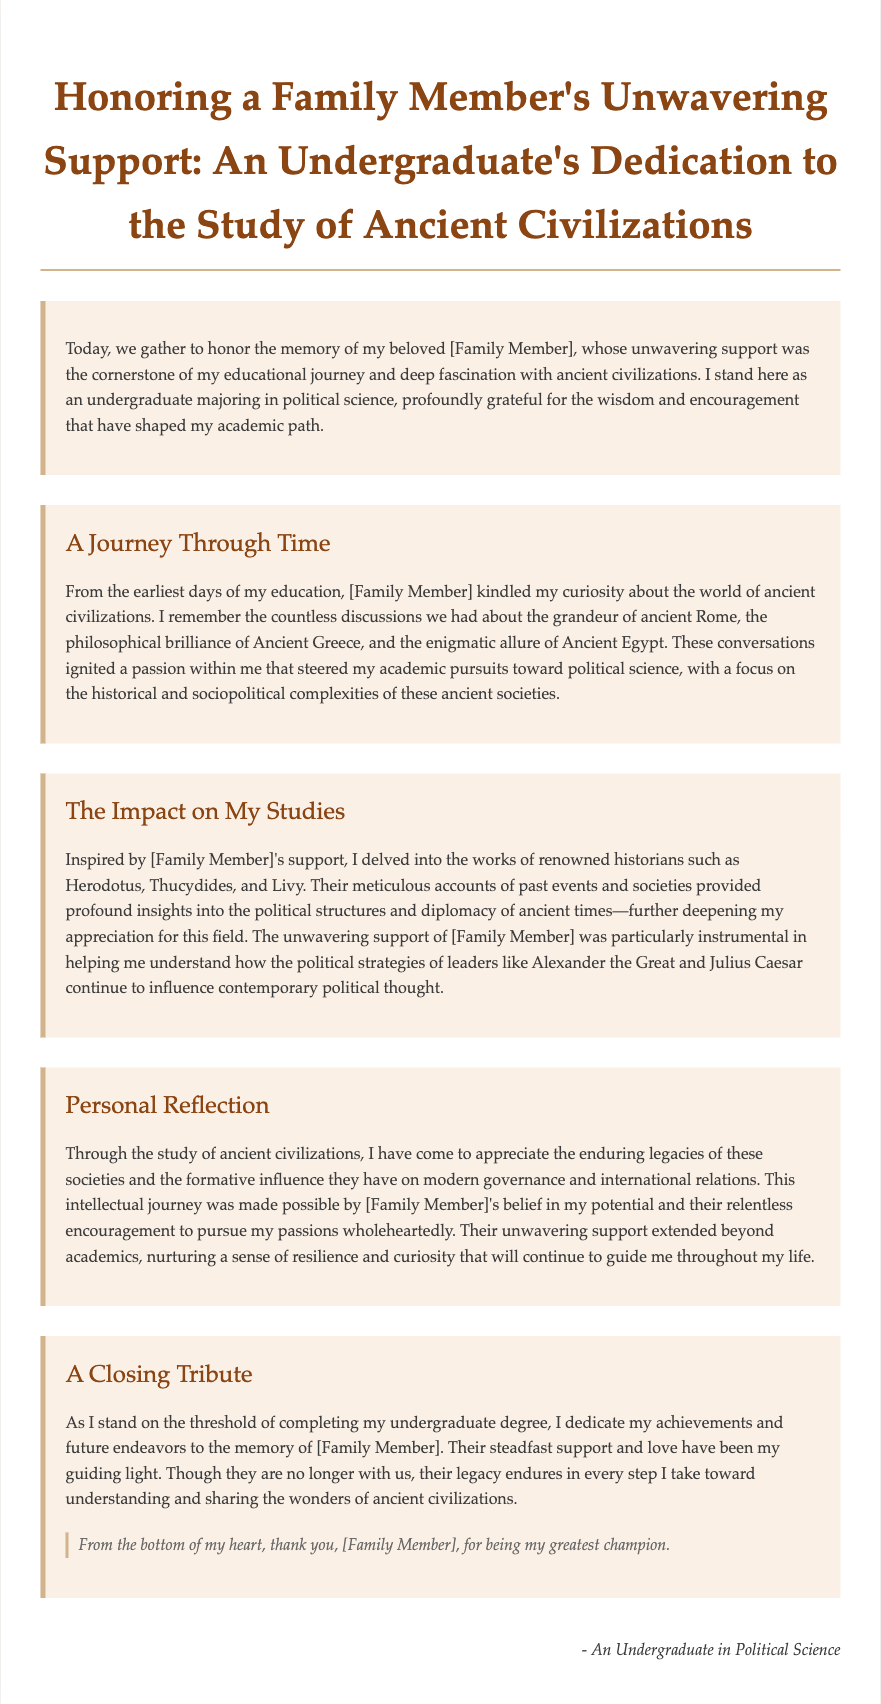What is the title of the eulogy? The title is found at the top of the document, summarizing its purpose and content.
Answer: Honoring a Family Member's Unwavering Support: An Undergraduate's Dedication to the Study of Ancient Civilizations Who is the primary subject of the eulogy? The document's content is oriented around the family member's significance in the speaker's life and education.
Answer: [Family Member] What field is the speaker majoring in? The document explicitly states the speaker's academic focus as part of their identity and dedication.
Answer: Political science Which ancient civilizations are mentioned in the eulogy? The eulogy discusses specific ancient societies that influenced the speaker's education and interests.
Answer: Ancient Rome, Ancient Greece, Ancient Egypt What significant historians' works did the speaker delve into? The document lists prominent historians whose contributions are highlighted throughout the narrative.
Answer: Herodotus, Thucydides, Livy What quality did the speaker attribute to the family member? The attribute reflects the family member's role in supporting the speaker's ambitions and overcoming challenges.
Answer: Unwavering support What is the speaker's academic focus regarding ancient civilizations? The focus is elaborated on how it relates to their understanding of political structures and diplomacy.
Answer: Historical and sociopolitical complexities What does the speaker dedicate to the memory of the family member? The eulogy mentions a direct tribute that acknowledges the influence of the family member on the speaker's achievements.
Answer: Achievements and future endeavors 